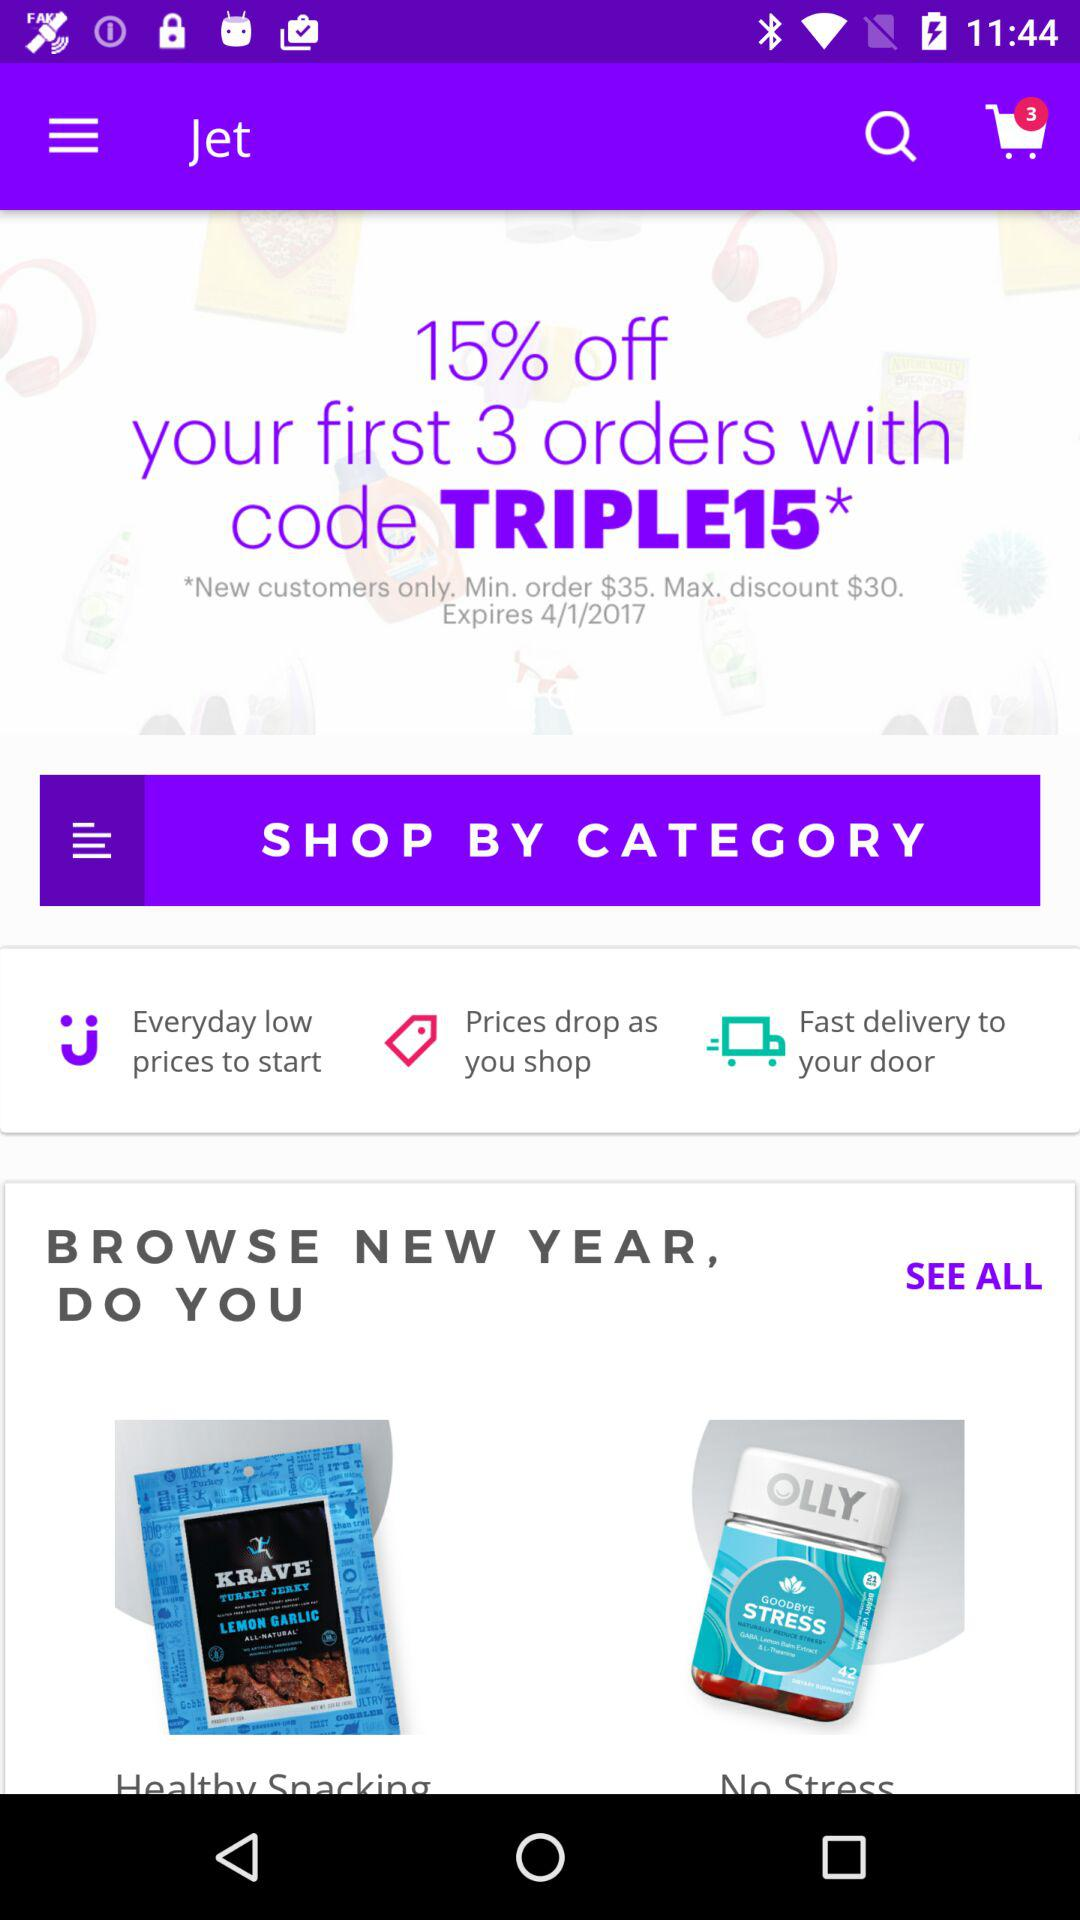What is the minimum purchase amount?
When the provided information is insufficient, respond with <no answer>. <no answer> 